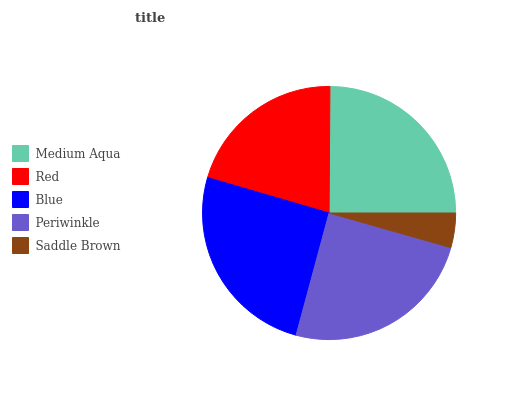Is Saddle Brown the minimum?
Answer yes or no. Yes. Is Blue the maximum?
Answer yes or no. Yes. Is Red the minimum?
Answer yes or no. No. Is Red the maximum?
Answer yes or no. No. Is Medium Aqua greater than Red?
Answer yes or no. Yes. Is Red less than Medium Aqua?
Answer yes or no. Yes. Is Red greater than Medium Aqua?
Answer yes or no. No. Is Medium Aqua less than Red?
Answer yes or no. No. Is Periwinkle the high median?
Answer yes or no. Yes. Is Periwinkle the low median?
Answer yes or no. Yes. Is Medium Aqua the high median?
Answer yes or no. No. Is Medium Aqua the low median?
Answer yes or no. No. 